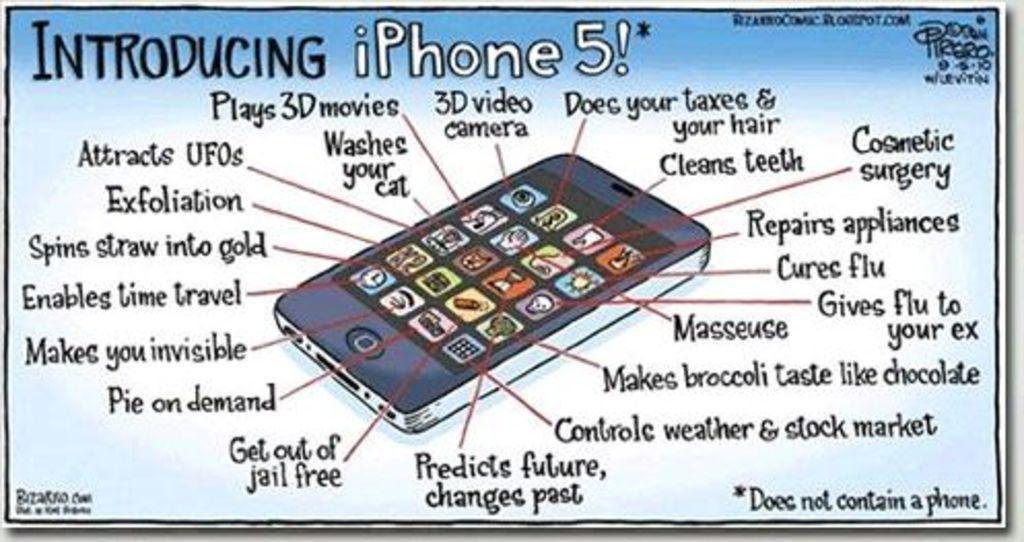Provide a one-sentence caption for the provided image. A cartoon like drawing of and Iphone 5 introducing the product and its features. 